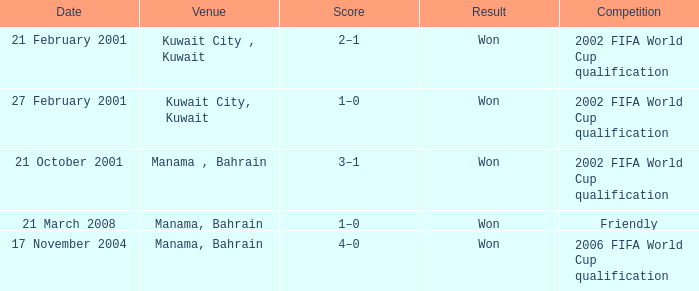On which date was the 2006 FIFA World Cup Qualification in Manama, Bahrain? 17 November 2004. 